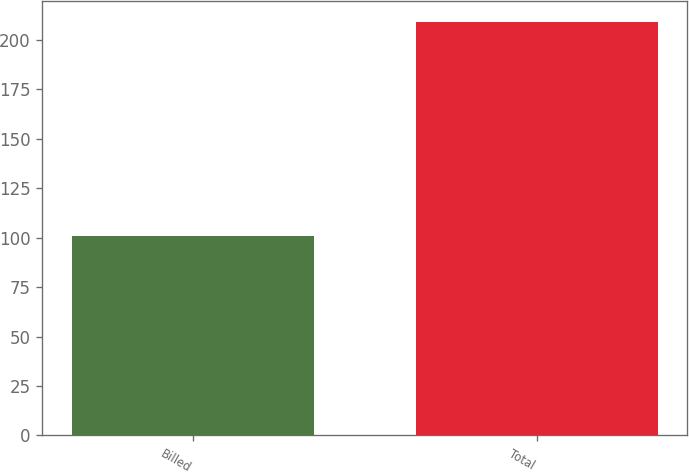Convert chart. <chart><loc_0><loc_0><loc_500><loc_500><bar_chart><fcel>Billed<fcel>Total<nl><fcel>101<fcel>209<nl></chart> 